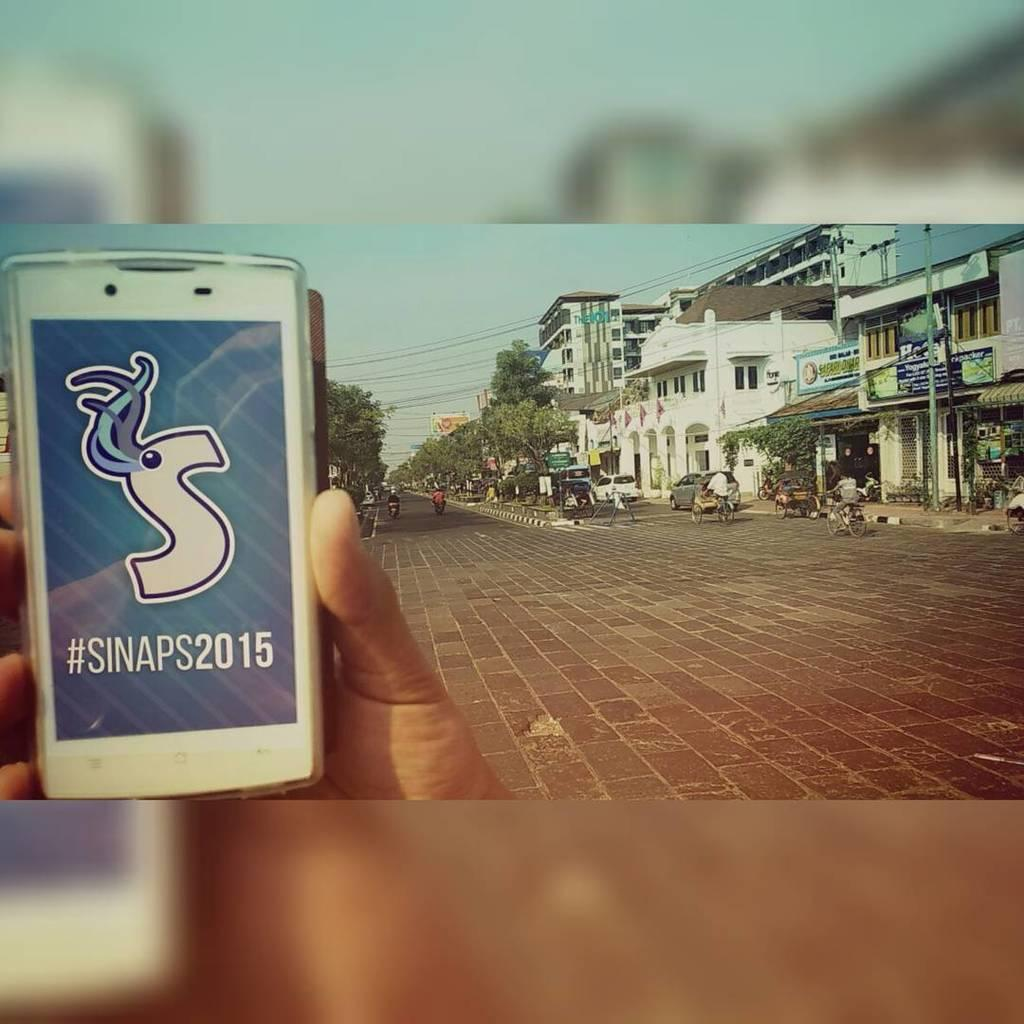<image>
Share a concise interpretation of the image provided. Someone holding a phone  that the phone reads "#SINAPS2015"  on a street with 